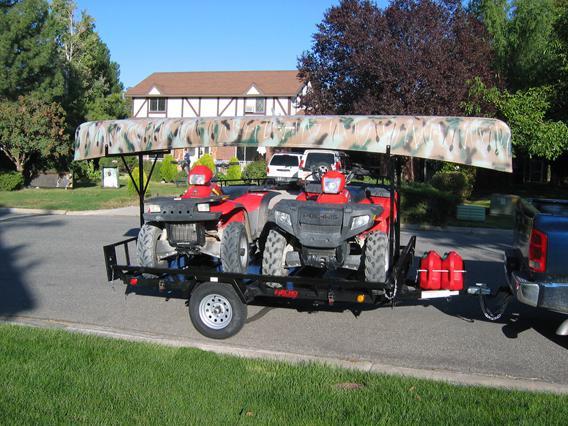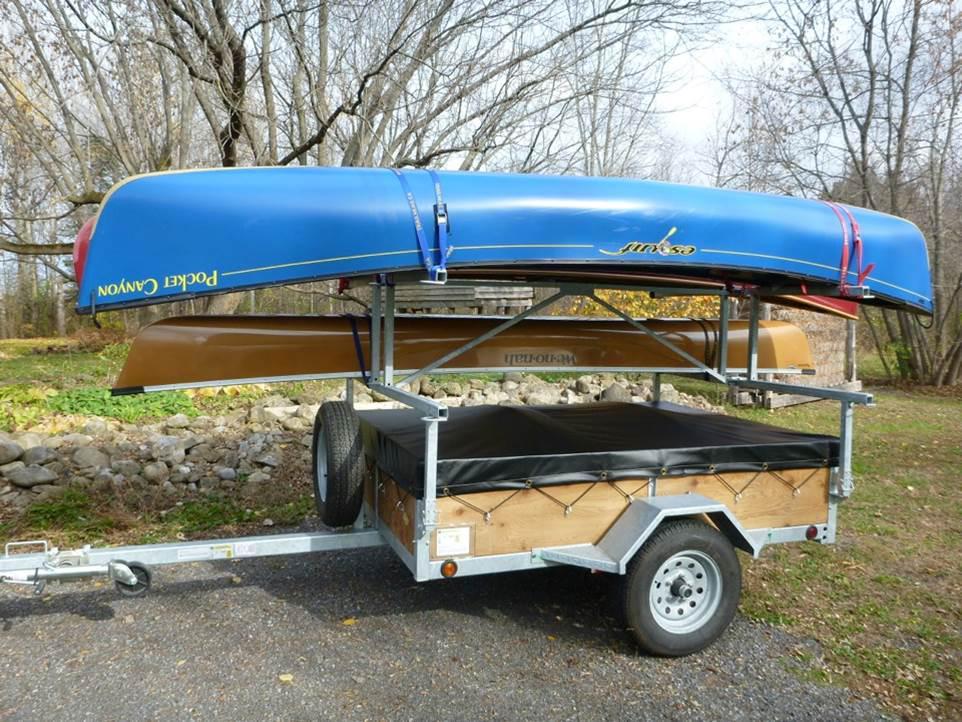The first image is the image on the left, the second image is the image on the right. Evaluate the accuracy of this statement regarding the images: "One trailer is loaded with at least one boat, while the other is loaded with at least one boat plus other riding vehicles.". Is it true? Answer yes or no. Yes. The first image is the image on the left, the second image is the image on the right. Evaluate the accuracy of this statement regarding the images: "Two canoes of the same color are on a trailer.". Is it true? Answer yes or no. No. 